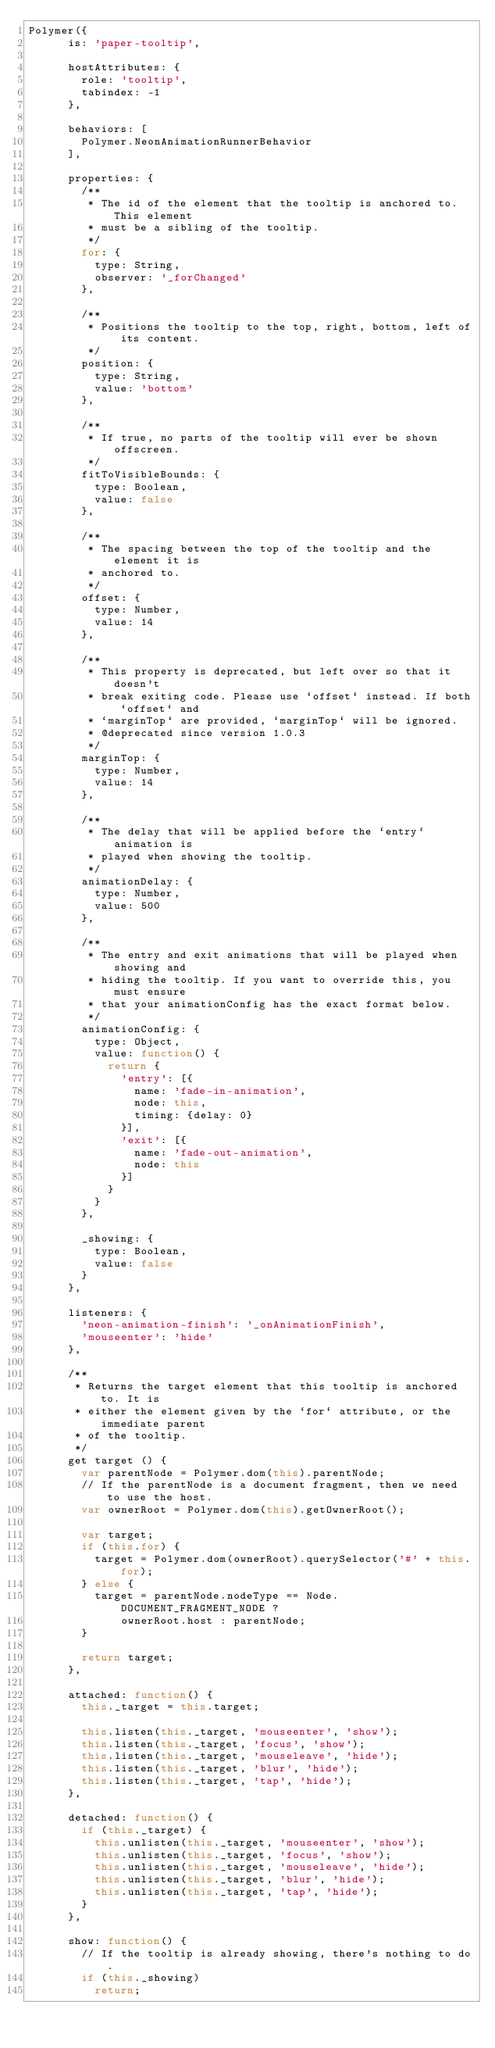Convert code to text. <code><loc_0><loc_0><loc_500><loc_500><_JavaScript_>Polymer({
      is: 'paper-tooltip',

      hostAttributes: {
        role: 'tooltip',
        tabindex: -1
      },

      behaviors: [
        Polymer.NeonAnimationRunnerBehavior
      ],

      properties: {
        /**
         * The id of the element that the tooltip is anchored to. This element
         * must be a sibling of the tooltip.
         */
        for: {
          type: String,
          observer: '_forChanged'
        },

        /**
         * Positions the tooltip to the top, right, bottom, left of its content.
         */
        position: {
          type: String,
          value: 'bottom'
        },

        /**
         * If true, no parts of the tooltip will ever be shown offscreen.
         */
        fitToVisibleBounds: {
          type: Boolean,
          value: false
        },

        /**
         * The spacing between the top of the tooltip and the element it is
         * anchored to.
         */
        offset: {
          type: Number,
          value: 14
        },

        /**
         * This property is deprecated, but left over so that it doesn't
         * break exiting code. Please use `offset` instead. If both `offset` and
         * `marginTop` are provided, `marginTop` will be ignored.
         * @deprecated since version 1.0.3
         */
        marginTop: {
          type: Number,
          value: 14
        },

        /**
         * The delay that will be applied before the `entry` animation is
         * played when showing the tooltip.
         */
        animationDelay: {
          type: Number,
          value: 500
        },

        /**
         * The entry and exit animations that will be played when showing and
         * hiding the tooltip. If you want to override this, you must ensure
         * that your animationConfig has the exact format below.
         */
        animationConfig: {
          type: Object,
          value: function() {
            return {
              'entry': [{
                name: 'fade-in-animation',
                node: this,
                timing: {delay: 0}
              }],
              'exit': [{
                name: 'fade-out-animation',
                node: this
              }]
            }
          }
        },

        _showing: {
          type: Boolean,
          value: false
        }
      },

      listeners: {
        'neon-animation-finish': '_onAnimationFinish',
        'mouseenter': 'hide'
      },

      /**
       * Returns the target element that this tooltip is anchored to. It is
       * either the element given by the `for` attribute, or the immediate parent
       * of the tooltip.
       */
      get target () {
        var parentNode = Polymer.dom(this).parentNode;
        // If the parentNode is a document fragment, then we need to use the host.
        var ownerRoot = Polymer.dom(this).getOwnerRoot();

        var target;
        if (this.for) {
          target = Polymer.dom(ownerRoot).querySelector('#' + this.for);
        } else {
          target = parentNode.nodeType == Node.DOCUMENT_FRAGMENT_NODE ?
              ownerRoot.host : parentNode;
        }

        return target;
      },

      attached: function() {
        this._target = this.target;

        this.listen(this._target, 'mouseenter', 'show');
        this.listen(this._target, 'focus', 'show');
        this.listen(this._target, 'mouseleave', 'hide');
        this.listen(this._target, 'blur', 'hide');
        this.listen(this._target, 'tap', 'hide');
      },

      detached: function() {
        if (this._target) {
          this.unlisten(this._target, 'mouseenter', 'show');
          this.unlisten(this._target, 'focus', 'show');
          this.unlisten(this._target, 'mouseleave', 'hide');
          this.unlisten(this._target, 'blur', 'hide');
          this.unlisten(this._target, 'tap', 'hide');
        }
      },

      show: function() {
        // If the tooltip is already showing, there's nothing to do.
        if (this._showing)
          return;
</code> 